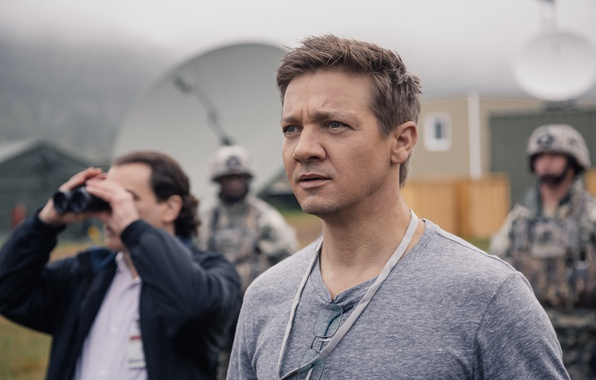Imagine a backstory for the central figure in the image. The central figure, John, is a seasoned intelligence officer stationed at a remote military base. With years of field experience, he has been assigned to oversee critical operations involving advanced surveillance and communication. Today, he's particularly focused due to an incoming high-stakes mission requiring precise coordination, which could have significant geopolitical implications. What do you think could be happening out of the frame that he is looking at so intently? Out of the frame, a vital reconnaissance operation might be unfolding. John could be receiving live updates from a team in the field or monitoring an approaching threat via the satellite dishes seen in the background. His intense gaze suggests the gravity of the situation and his deep involvement in ensuring its success. In a wildly imaginative scenario, what if the setting was part of an alien contact event? How might the story change? In a wildly imaginative scenario, this image could depict the tense moments just before first contact with an alien species. John, part of a secret government task force, might be observing the arrival of extraterrestrial beings through the binoculars. The satellite dishes serve as communication devices to decipher alien signals, and the lanyard is equipped with specialized identification to access secure areas. His serious expression reflects the monumental nature of the event, contemplating the future impact of this unprecedented encounter on humanity. 